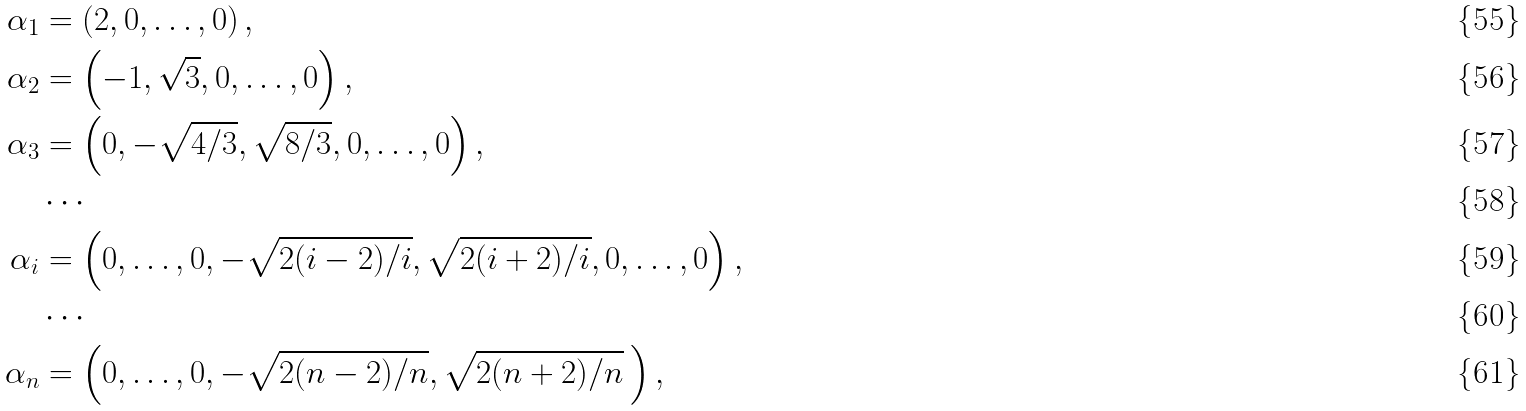Convert formula to latex. <formula><loc_0><loc_0><loc_500><loc_500>\alpha _ { 1 } & = \left ( 2 , 0 , \dots , 0 \right ) , \\ \alpha _ { 2 } & = \left ( - 1 , \sqrt { 3 } , 0 , \dots , 0 \right ) , \\ \alpha _ { 3 } & = \left ( 0 , - \sqrt { 4 / 3 } , \sqrt { 8 / 3 } , 0 , \dots , 0 \right ) , \\ & \cdots \\ \alpha _ { i } & = \left ( 0 , \dots , 0 , - \sqrt { 2 ( i - 2 ) / i } , \sqrt { 2 ( i + 2 ) / i } , 0 , \dots , 0 \right ) , \\ & \cdots \\ \alpha _ { n } & = \left ( 0 , \dots , 0 , - \sqrt { 2 ( n - 2 ) / n } , \sqrt { 2 ( n + 2 ) / n } \, \right ) ,</formula> 